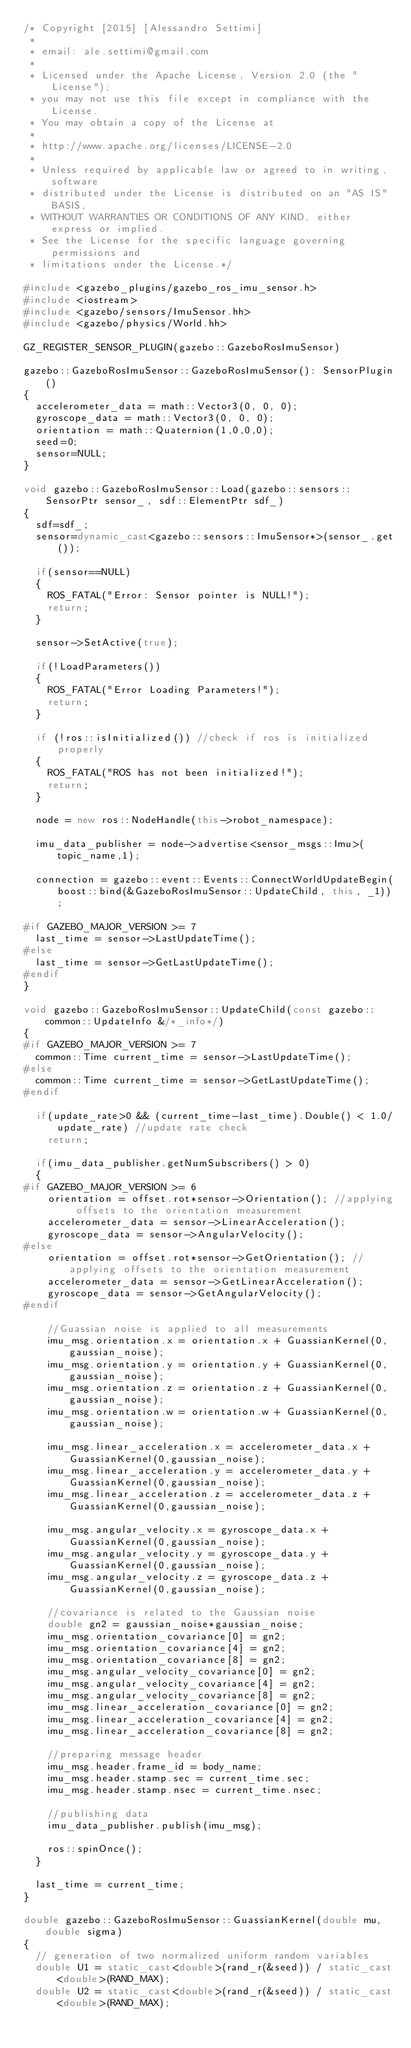Convert code to text. <code><loc_0><loc_0><loc_500><loc_500><_C++_>/* Copyright [2015] [Alessandro Settimi]
 * 
 * email: ale.settimi@gmail.com
 * 
 * Licensed under the Apache License, Version 2.0 (the "License");
 * you may not use this file except in compliance with the License.
 * You may obtain a copy of the License at
 * 
 * http://www.apache.org/licenses/LICENSE-2.0
 * 
 * Unless required by applicable law or agreed to in writing, software
 * distributed under the License is distributed on an "AS IS" BASIS,
 * WITHOUT WARRANTIES OR CONDITIONS OF ANY KIND, either express or implied.
 * See the License for the specific language governing permissions and
 * limitations under the License.*/

#include <gazebo_plugins/gazebo_ros_imu_sensor.h>
#include <iostream>
#include <gazebo/sensors/ImuSensor.hh>
#include <gazebo/physics/World.hh>

GZ_REGISTER_SENSOR_PLUGIN(gazebo::GazeboRosImuSensor)

gazebo::GazeboRosImuSensor::GazeboRosImuSensor(): SensorPlugin()
{
  accelerometer_data = math::Vector3(0, 0, 0);
  gyroscope_data = math::Vector3(0, 0, 0);
  orientation = math::Quaternion(1,0,0,0);
  seed=0;
  sensor=NULL;
}

void gazebo::GazeboRosImuSensor::Load(gazebo::sensors::SensorPtr sensor_, sdf::ElementPtr sdf_)
{
  sdf=sdf_;
  sensor=dynamic_cast<gazebo::sensors::ImuSensor*>(sensor_.get());

  if(sensor==NULL)
  {
    ROS_FATAL("Error: Sensor pointer is NULL!");
    return;
  }

  sensor->SetActive(true);

  if(!LoadParameters())
  {
    ROS_FATAL("Error Loading Parameters!");
    return;
  }

  if (!ros::isInitialized()) //check if ros is initialized properly
  {
    ROS_FATAL("ROS has not been initialized!");
    return;
  }

  node = new ros::NodeHandle(this->robot_namespace);

  imu_data_publisher = node->advertise<sensor_msgs::Imu>(topic_name,1);

  connection = gazebo::event::Events::ConnectWorldUpdateBegin(boost::bind(&GazeboRosImuSensor::UpdateChild, this, _1));

#if GAZEBO_MAJOR_VERSION >= 7
  last_time = sensor->LastUpdateTime();
#else
  last_time = sensor->GetLastUpdateTime();
#endif
}

void gazebo::GazeboRosImuSensor::UpdateChild(const gazebo::common::UpdateInfo &/*_info*/)
{
#if GAZEBO_MAJOR_VERSION >= 7
  common::Time current_time = sensor->LastUpdateTime();
#else
  common::Time current_time = sensor->GetLastUpdateTime();
#endif

  if(update_rate>0 && (current_time-last_time).Double() < 1.0/update_rate) //update rate check
    return;

  if(imu_data_publisher.getNumSubscribers() > 0)
  {
#if GAZEBO_MAJOR_VERSION >= 6
    orientation = offset.rot*sensor->Orientation(); //applying offsets to the orientation measurement
    accelerometer_data = sensor->LinearAcceleration();
    gyroscope_data = sensor->AngularVelocity();
#else
    orientation = offset.rot*sensor->GetOrientation(); //applying offsets to the orientation measurement
    accelerometer_data = sensor->GetLinearAcceleration();
    gyroscope_data = sensor->GetAngularVelocity();
#endif

    //Guassian noise is applied to all measurements
    imu_msg.orientation.x = orientation.x + GuassianKernel(0,gaussian_noise);
    imu_msg.orientation.y = orientation.y + GuassianKernel(0,gaussian_noise);
    imu_msg.orientation.z = orientation.z + GuassianKernel(0,gaussian_noise);
    imu_msg.orientation.w = orientation.w + GuassianKernel(0,gaussian_noise);

    imu_msg.linear_acceleration.x = accelerometer_data.x + GuassianKernel(0,gaussian_noise);
    imu_msg.linear_acceleration.y = accelerometer_data.y + GuassianKernel(0,gaussian_noise);
    imu_msg.linear_acceleration.z = accelerometer_data.z + GuassianKernel(0,gaussian_noise);

    imu_msg.angular_velocity.x = gyroscope_data.x + GuassianKernel(0,gaussian_noise);
    imu_msg.angular_velocity.y = gyroscope_data.y + GuassianKernel(0,gaussian_noise);
    imu_msg.angular_velocity.z = gyroscope_data.z + GuassianKernel(0,gaussian_noise);

    //covariance is related to the Gaussian noise
    double gn2 = gaussian_noise*gaussian_noise;
    imu_msg.orientation_covariance[0] = gn2;
    imu_msg.orientation_covariance[4] = gn2;
    imu_msg.orientation_covariance[8] = gn2;
    imu_msg.angular_velocity_covariance[0] = gn2;
    imu_msg.angular_velocity_covariance[4] = gn2;
    imu_msg.angular_velocity_covariance[8] = gn2;
    imu_msg.linear_acceleration_covariance[0] = gn2;
    imu_msg.linear_acceleration_covariance[4] = gn2;
    imu_msg.linear_acceleration_covariance[8] = gn2;

    //preparing message header
    imu_msg.header.frame_id = body_name;
    imu_msg.header.stamp.sec = current_time.sec;
    imu_msg.header.stamp.nsec = current_time.nsec;

    //publishing data
    imu_data_publisher.publish(imu_msg);

    ros::spinOnce();
  }

  last_time = current_time;
}

double gazebo::GazeboRosImuSensor::GuassianKernel(double mu, double sigma)
{
  // generation of two normalized uniform random variables
  double U1 = static_cast<double>(rand_r(&seed)) / static_cast<double>(RAND_MAX);
  double U2 = static_cast<double>(rand_r(&seed)) / static_cast<double>(RAND_MAX);
</code> 